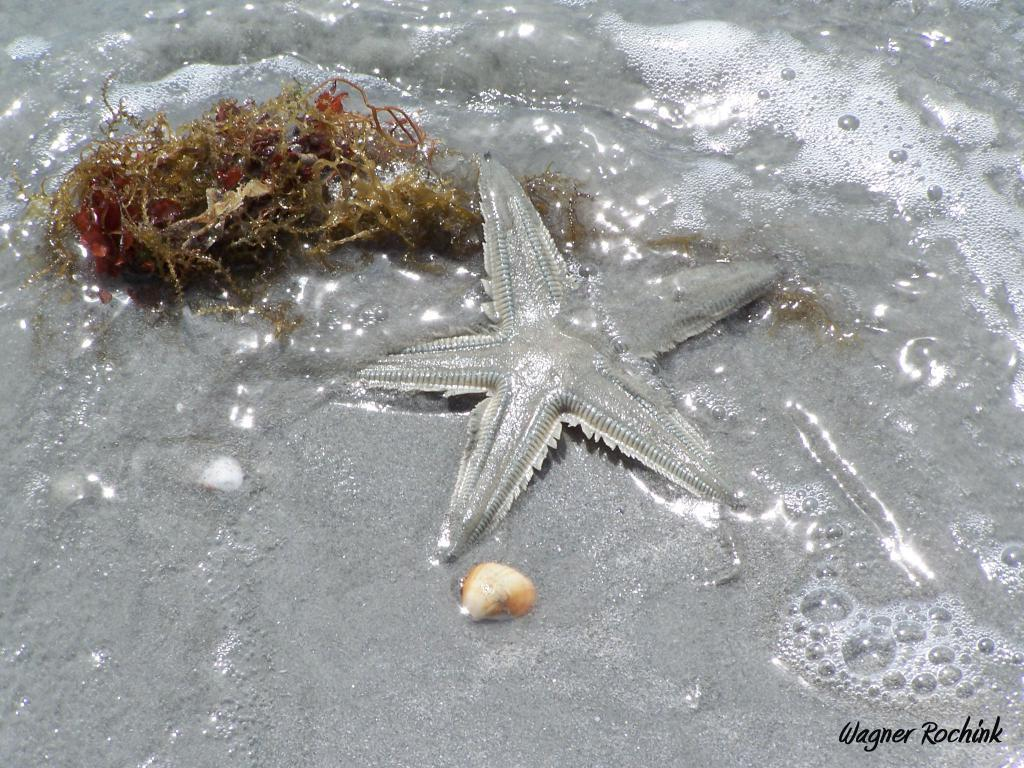What type of marine animal is in the image? There is a starfish in the image. What other marine object can be seen in the image? There is a seashell in the image. What is the primary element visible in the image? There is water visible in the image. Can you describe the object in the image? There is an object in the image, but its specific nature is not clear from the provided facts. What is written at the bottom of the image? There is writing at the bottom of the image. What type of toys are being used by the starfish in the image? There are no toys present in the image, as it features a starfish and a seashell in water. 